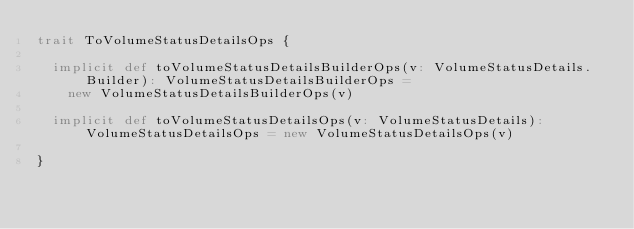Convert code to text. <code><loc_0><loc_0><loc_500><loc_500><_Scala_>trait ToVolumeStatusDetailsOps {

  implicit def toVolumeStatusDetailsBuilderOps(v: VolumeStatusDetails.Builder): VolumeStatusDetailsBuilderOps =
    new VolumeStatusDetailsBuilderOps(v)

  implicit def toVolumeStatusDetailsOps(v: VolumeStatusDetails): VolumeStatusDetailsOps = new VolumeStatusDetailsOps(v)

}
</code> 